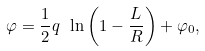Convert formula to latex. <formula><loc_0><loc_0><loc_500><loc_500>\varphi = \frac { 1 } { 2 } q \ \ln \left ( 1 - \frac { L } { R } \right ) + \varphi _ { 0 } ,</formula> 